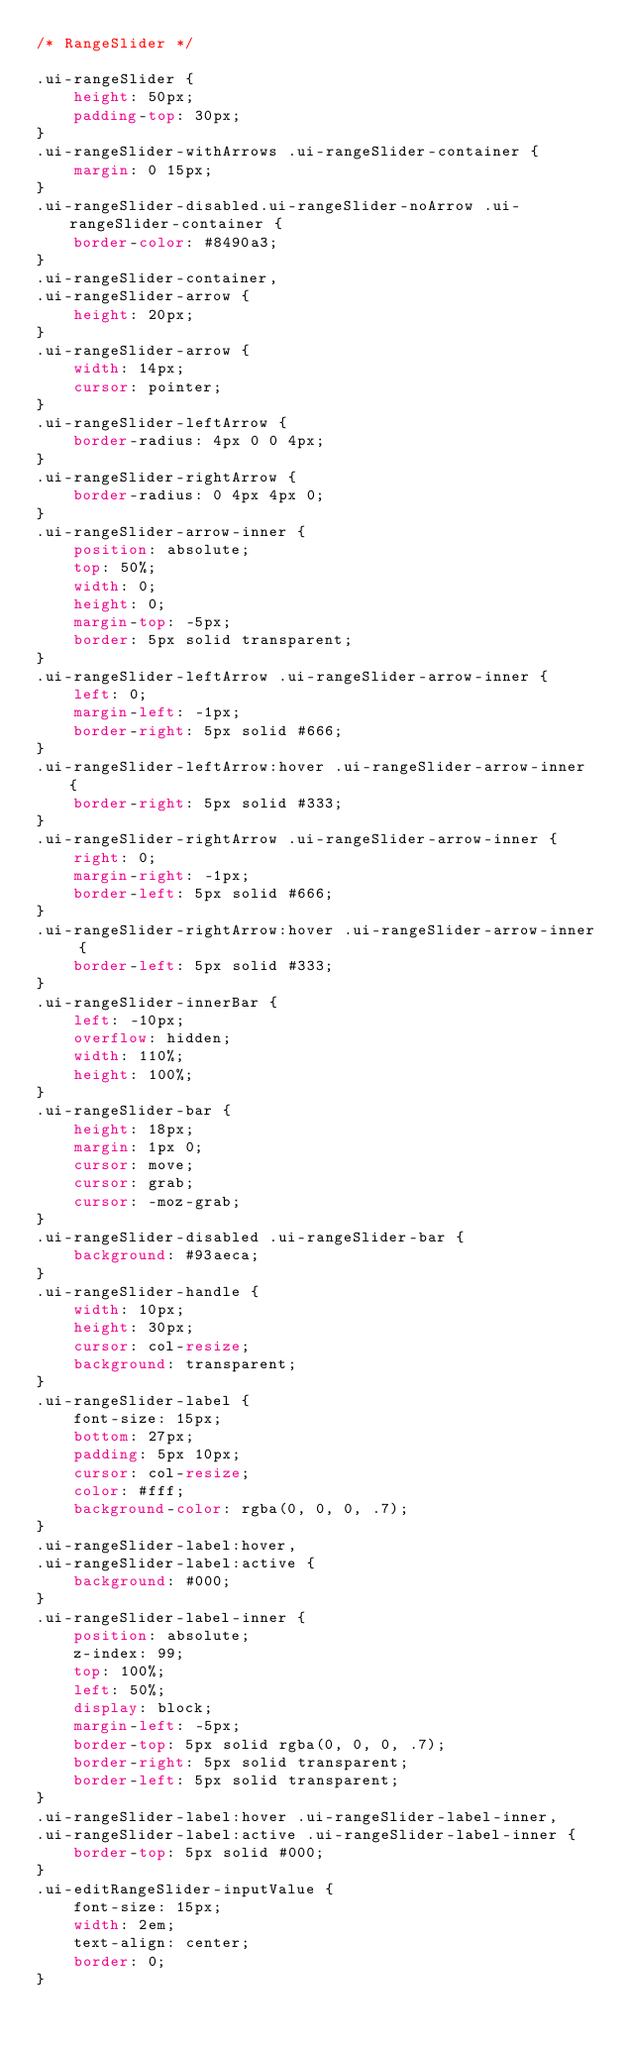<code> <loc_0><loc_0><loc_500><loc_500><_CSS_>/* RangeSlider */

.ui-rangeSlider {
    height: 50px;
    padding-top: 30px;
}
.ui-rangeSlider-withArrows .ui-rangeSlider-container {
    margin: 0 15px;
}
.ui-rangeSlider-disabled.ui-rangeSlider-noArrow .ui-rangeSlider-container {
    border-color: #8490a3;
}
.ui-rangeSlider-container,
.ui-rangeSlider-arrow {
    height: 20px;
}
.ui-rangeSlider-arrow {
    width: 14px;
    cursor: pointer;
}
.ui-rangeSlider-leftArrow {
    border-radius: 4px 0 0 4px;
}
.ui-rangeSlider-rightArrow {
    border-radius: 0 4px 4px 0;
}
.ui-rangeSlider-arrow-inner {
    position: absolute;
    top: 50%;
    width: 0;
    height: 0;
    margin-top: -5px;
    border: 5px solid transparent;
}
.ui-rangeSlider-leftArrow .ui-rangeSlider-arrow-inner {
    left: 0;
    margin-left: -1px;
    border-right: 5px solid #666;
}
.ui-rangeSlider-leftArrow:hover .ui-rangeSlider-arrow-inner {
    border-right: 5px solid #333;
}
.ui-rangeSlider-rightArrow .ui-rangeSlider-arrow-inner {
    right: 0;
    margin-right: -1px;
    border-left: 5px solid #666;
}
.ui-rangeSlider-rightArrow:hover .ui-rangeSlider-arrow-inner {
    border-left: 5px solid #333;
}
.ui-rangeSlider-innerBar {
    left: -10px;
    overflow: hidden;
    width: 110%;
    height: 100%;
}
.ui-rangeSlider-bar {
    height: 18px;
    margin: 1px 0;
    cursor: move;
    cursor: grab;
    cursor: -moz-grab;
}
.ui-rangeSlider-disabled .ui-rangeSlider-bar {
    background: #93aeca;
}
.ui-rangeSlider-handle {
    width: 10px;
    height: 30px;
    cursor: col-resize;
    background: transparent;
}
.ui-rangeSlider-label {
    font-size: 15px;
    bottom: 27px;
    padding: 5px 10px;
    cursor: col-resize;
    color: #fff;
    background-color: rgba(0, 0, 0, .7);
}
.ui-rangeSlider-label:hover,
.ui-rangeSlider-label:active {
    background: #000;
}
.ui-rangeSlider-label-inner {
    position: absolute;
    z-index: 99;
    top: 100%;
    left: 50%;
    display: block;
    margin-left: -5px;
    border-top: 5px solid rgba(0, 0, 0, .7);
    border-right: 5px solid transparent;
    border-left: 5px solid transparent;
}
.ui-rangeSlider-label:hover .ui-rangeSlider-label-inner,
.ui-rangeSlider-label:active .ui-rangeSlider-label-inner {
    border-top: 5px solid #000;
}
.ui-editRangeSlider-inputValue {
    font-size: 15px;
    width: 2em;
    text-align: center;
    border: 0;
}
</code> 